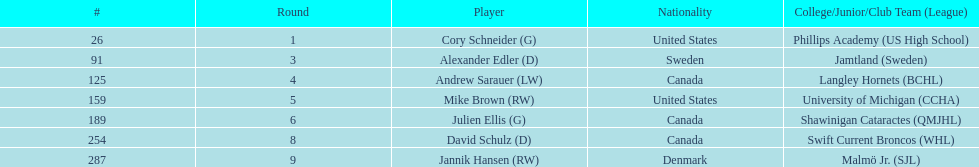List each player drafted from canada. Andrew Sarauer (LW), Julien Ellis (G), David Schulz (D). 